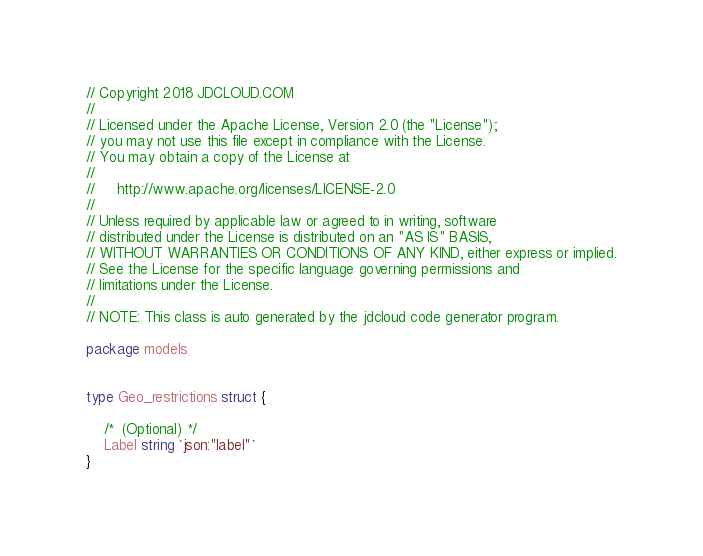Convert code to text. <code><loc_0><loc_0><loc_500><loc_500><_Go_>// Copyright 2018 JDCLOUD.COM
//
// Licensed under the Apache License, Version 2.0 (the "License");
// you may not use this file except in compliance with the License.
// You may obtain a copy of the License at
//
//     http://www.apache.org/licenses/LICENSE-2.0
//
// Unless required by applicable law or agreed to in writing, software
// distributed under the License is distributed on an "AS IS" BASIS,
// WITHOUT WARRANTIES OR CONDITIONS OF ANY KIND, either express or implied.
// See the License for the specific language governing permissions and
// limitations under the License.
//
// NOTE: This class is auto generated by the jdcloud code generator program.

package models


type Geo_restrictions struct {

    /*  (Optional) */
    Label string `json:"label"`
}
</code> 